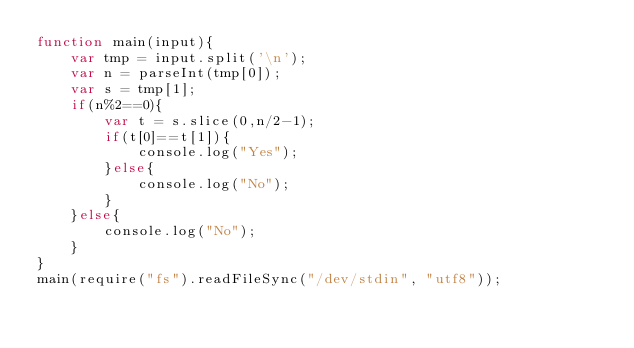Convert code to text. <code><loc_0><loc_0><loc_500><loc_500><_JavaScript_>function main(input){
    var tmp = input.split('\n');
    var n = parseInt(tmp[0]);
    var s = tmp[1];
    if(n%2==0){
        var t = s.slice(0,n/2-1);
        if(t[0]==t[1]){
            console.log("Yes");
        }else{
            console.log("No");
        }
    }else{
        console.log("No");
    }
}
main(require("fs").readFileSync("/dev/stdin", "utf8"));</code> 